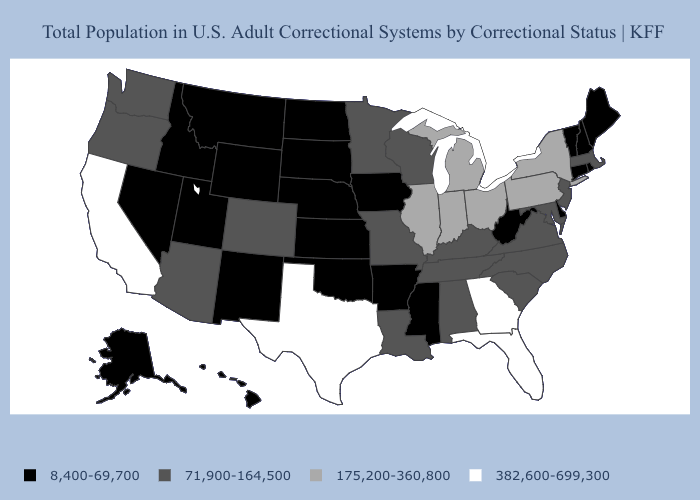What is the value of Florida?
Write a very short answer. 382,600-699,300. What is the lowest value in the USA?
Be succinct. 8,400-69,700. What is the lowest value in the South?
Short answer required. 8,400-69,700. Which states have the lowest value in the MidWest?
Keep it brief. Iowa, Kansas, Nebraska, North Dakota, South Dakota. What is the value of Alabama?
Answer briefly. 71,900-164,500. What is the value of Hawaii?
Short answer required. 8,400-69,700. What is the value of Mississippi?
Quick response, please. 8,400-69,700. What is the highest value in states that border New Mexico?
Concise answer only. 382,600-699,300. Among the states that border Arizona , does California have the highest value?
Quick response, please. Yes. What is the highest value in the Northeast ?
Concise answer only. 175,200-360,800. What is the value of Oklahoma?
Answer briefly. 8,400-69,700. Does Montana have the lowest value in the USA?
Concise answer only. Yes. Among the states that border Oklahoma , which have the lowest value?
Be succinct. Arkansas, Kansas, New Mexico. Does the first symbol in the legend represent the smallest category?
Answer briefly. Yes. What is the value of North Dakota?
Quick response, please. 8,400-69,700. 